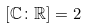Convert formula to latex. <formula><loc_0><loc_0><loc_500><loc_500>[ \mathbb { C } \colon \mathbb { R } ] = 2</formula> 